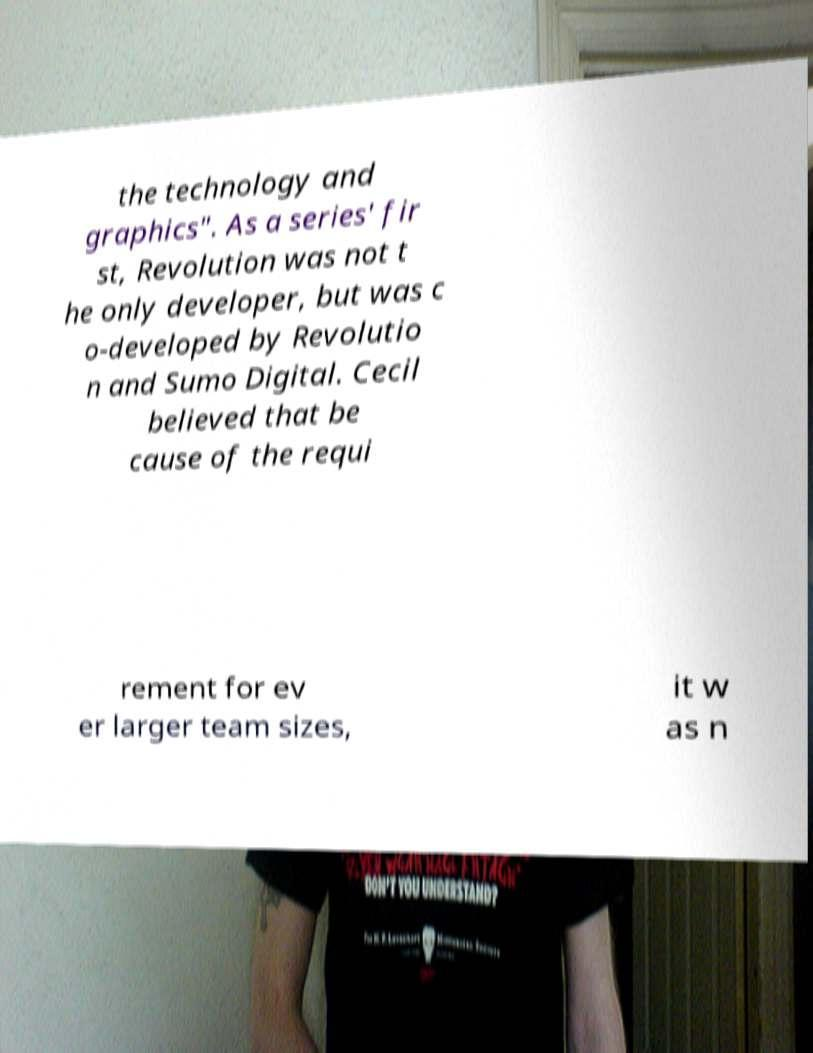Can you accurately transcribe the text from the provided image for me? the technology and graphics". As a series' fir st, Revolution was not t he only developer, but was c o-developed by Revolutio n and Sumo Digital. Cecil believed that be cause of the requi rement for ev er larger team sizes, it w as n 